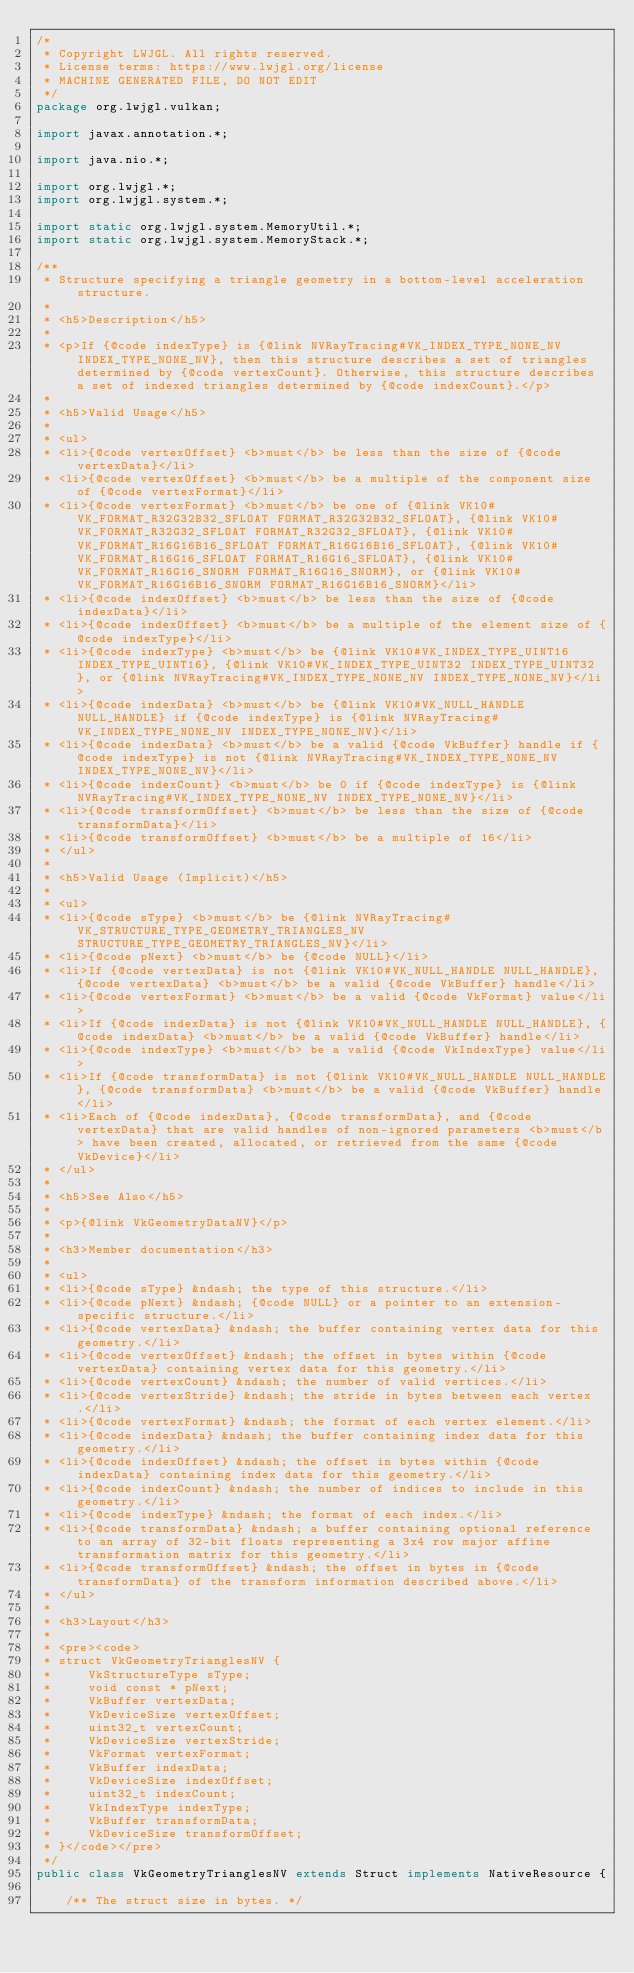<code> <loc_0><loc_0><loc_500><loc_500><_Java_>/*
 * Copyright LWJGL. All rights reserved.
 * License terms: https://www.lwjgl.org/license
 * MACHINE GENERATED FILE, DO NOT EDIT
 */
package org.lwjgl.vulkan;

import javax.annotation.*;

import java.nio.*;

import org.lwjgl.*;
import org.lwjgl.system.*;

import static org.lwjgl.system.MemoryUtil.*;
import static org.lwjgl.system.MemoryStack.*;

/**
 * Structure specifying a triangle geometry in a bottom-level acceleration structure.
 * 
 * <h5>Description</h5>
 * 
 * <p>If {@code indexType} is {@link NVRayTracing#VK_INDEX_TYPE_NONE_NV INDEX_TYPE_NONE_NV}, then this structure describes a set of triangles determined by {@code vertexCount}. Otherwise, this structure describes a set of indexed triangles determined by {@code indexCount}.</p>
 * 
 * <h5>Valid Usage</h5>
 * 
 * <ul>
 * <li>{@code vertexOffset} <b>must</b> be less than the size of {@code vertexData}</li>
 * <li>{@code vertexOffset} <b>must</b> be a multiple of the component size of {@code vertexFormat}</li>
 * <li>{@code vertexFormat} <b>must</b> be one of {@link VK10#VK_FORMAT_R32G32B32_SFLOAT FORMAT_R32G32B32_SFLOAT}, {@link VK10#VK_FORMAT_R32G32_SFLOAT FORMAT_R32G32_SFLOAT}, {@link VK10#VK_FORMAT_R16G16B16_SFLOAT FORMAT_R16G16B16_SFLOAT}, {@link VK10#VK_FORMAT_R16G16_SFLOAT FORMAT_R16G16_SFLOAT}, {@link VK10#VK_FORMAT_R16G16_SNORM FORMAT_R16G16_SNORM}, or {@link VK10#VK_FORMAT_R16G16B16_SNORM FORMAT_R16G16B16_SNORM}</li>
 * <li>{@code indexOffset} <b>must</b> be less than the size of {@code indexData}</li>
 * <li>{@code indexOffset} <b>must</b> be a multiple of the element size of {@code indexType}</li>
 * <li>{@code indexType} <b>must</b> be {@link VK10#VK_INDEX_TYPE_UINT16 INDEX_TYPE_UINT16}, {@link VK10#VK_INDEX_TYPE_UINT32 INDEX_TYPE_UINT32}, or {@link NVRayTracing#VK_INDEX_TYPE_NONE_NV INDEX_TYPE_NONE_NV}</li>
 * <li>{@code indexData} <b>must</b> be {@link VK10#VK_NULL_HANDLE NULL_HANDLE} if {@code indexType} is {@link NVRayTracing#VK_INDEX_TYPE_NONE_NV INDEX_TYPE_NONE_NV}</li>
 * <li>{@code indexData} <b>must</b> be a valid {@code VkBuffer} handle if {@code indexType} is not {@link NVRayTracing#VK_INDEX_TYPE_NONE_NV INDEX_TYPE_NONE_NV}</li>
 * <li>{@code indexCount} <b>must</b> be 0 if {@code indexType} is {@link NVRayTracing#VK_INDEX_TYPE_NONE_NV INDEX_TYPE_NONE_NV}</li>
 * <li>{@code transformOffset} <b>must</b> be less than the size of {@code transformData}</li>
 * <li>{@code transformOffset} <b>must</b> be a multiple of 16</li>
 * </ul>
 * 
 * <h5>Valid Usage (Implicit)</h5>
 * 
 * <ul>
 * <li>{@code sType} <b>must</b> be {@link NVRayTracing#VK_STRUCTURE_TYPE_GEOMETRY_TRIANGLES_NV STRUCTURE_TYPE_GEOMETRY_TRIANGLES_NV}</li>
 * <li>{@code pNext} <b>must</b> be {@code NULL}</li>
 * <li>If {@code vertexData} is not {@link VK10#VK_NULL_HANDLE NULL_HANDLE}, {@code vertexData} <b>must</b> be a valid {@code VkBuffer} handle</li>
 * <li>{@code vertexFormat} <b>must</b> be a valid {@code VkFormat} value</li>
 * <li>If {@code indexData} is not {@link VK10#VK_NULL_HANDLE NULL_HANDLE}, {@code indexData} <b>must</b> be a valid {@code VkBuffer} handle</li>
 * <li>{@code indexType} <b>must</b> be a valid {@code VkIndexType} value</li>
 * <li>If {@code transformData} is not {@link VK10#VK_NULL_HANDLE NULL_HANDLE}, {@code transformData} <b>must</b> be a valid {@code VkBuffer} handle</li>
 * <li>Each of {@code indexData}, {@code transformData}, and {@code vertexData} that are valid handles of non-ignored parameters <b>must</b> have been created, allocated, or retrieved from the same {@code VkDevice}</li>
 * </ul>
 * 
 * <h5>See Also</h5>
 * 
 * <p>{@link VkGeometryDataNV}</p>
 * 
 * <h3>Member documentation</h3>
 * 
 * <ul>
 * <li>{@code sType} &ndash; the type of this structure.</li>
 * <li>{@code pNext} &ndash; {@code NULL} or a pointer to an extension-specific structure.</li>
 * <li>{@code vertexData} &ndash; the buffer containing vertex data for this geometry.</li>
 * <li>{@code vertexOffset} &ndash; the offset in bytes within {@code vertexData} containing vertex data for this geometry.</li>
 * <li>{@code vertexCount} &ndash; the number of valid vertices.</li>
 * <li>{@code vertexStride} &ndash; the stride in bytes between each vertex.</li>
 * <li>{@code vertexFormat} &ndash; the format of each vertex element.</li>
 * <li>{@code indexData} &ndash; the buffer containing index data for this geometry.</li>
 * <li>{@code indexOffset} &ndash; the offset in bytes within {@code indexData} containing index data for this geometry.</li>
 * <li>{@code indexCount} &ndash; the number of indices to include in this geometry.</li>
 * <li>{@code indexType} &ndash; the format of each index.</li>
 * <li>{@code transformData} &ndash; a buffer containing optional reference to an array of 32-bit floats representing a 3x4 row major affine transformation matrix for this geometry.</li>
 * <li>{@code transformOffset} &ndash; the offset in bytes in {@code transformData} of the transform information described above.</li>
 * </ul>
 * 
 * <h3>Layout</h3>
 * 
 * <pre><code>
 * struct VkGeometryTrianglesNV {
 *     VkStructureType sType;
 *     void const * pNext;
 *     VkBuffer vertexData;
 *     VkDeviceSize vertexOffset;
 *     uint32_t vertexCount;
 *     VkDeviceSize vertexStride;
 *     VkFormat vertexFormat;
 *     VkBuffer indexData;
 *     VkDeviceSize indexOffset;
 *     uint32_t indexCount;
 *     VkIndexType indexType;
 *     VkBuffer transformData;
 *     VkDeviceSize transformOffset;
 * }</code></pre>
 */
public class VkGeometryTrianglesNV extends Struct implements NativeResource {

    /** The struct size in bytes. */</code> 